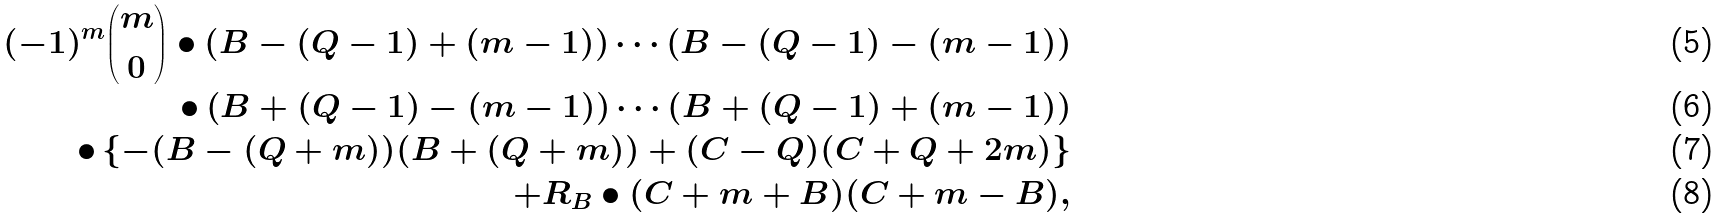Convert formula to latex. <formula><loc_0><loc_0><loc_500><loc_500>( - 1 ) ^ { m } \binom { m } { 0 } \bullet \left ( B - ( Q - 1 ) + ( m - 1 ) \right ) \cdots \left ( B - ( Q - 1 ) - ( m - 1 ) \right ) \\ \bullet \left ( B + ( Q - 1 ) - ( m - 1 ) \right ) \cdots \left ( B + ( Q - 1 ) + ( m - 1 ) \right ) \\ \bullet \left \{ - ( B - ( Q + m ) ) ( B + ( Q + m ) ) + ( C - Q ) ( C + Q + 2 m ) \right \} \\ + R _ { B } \bullet ( C + m + B ) ( C + m - B ) ,</formula> 